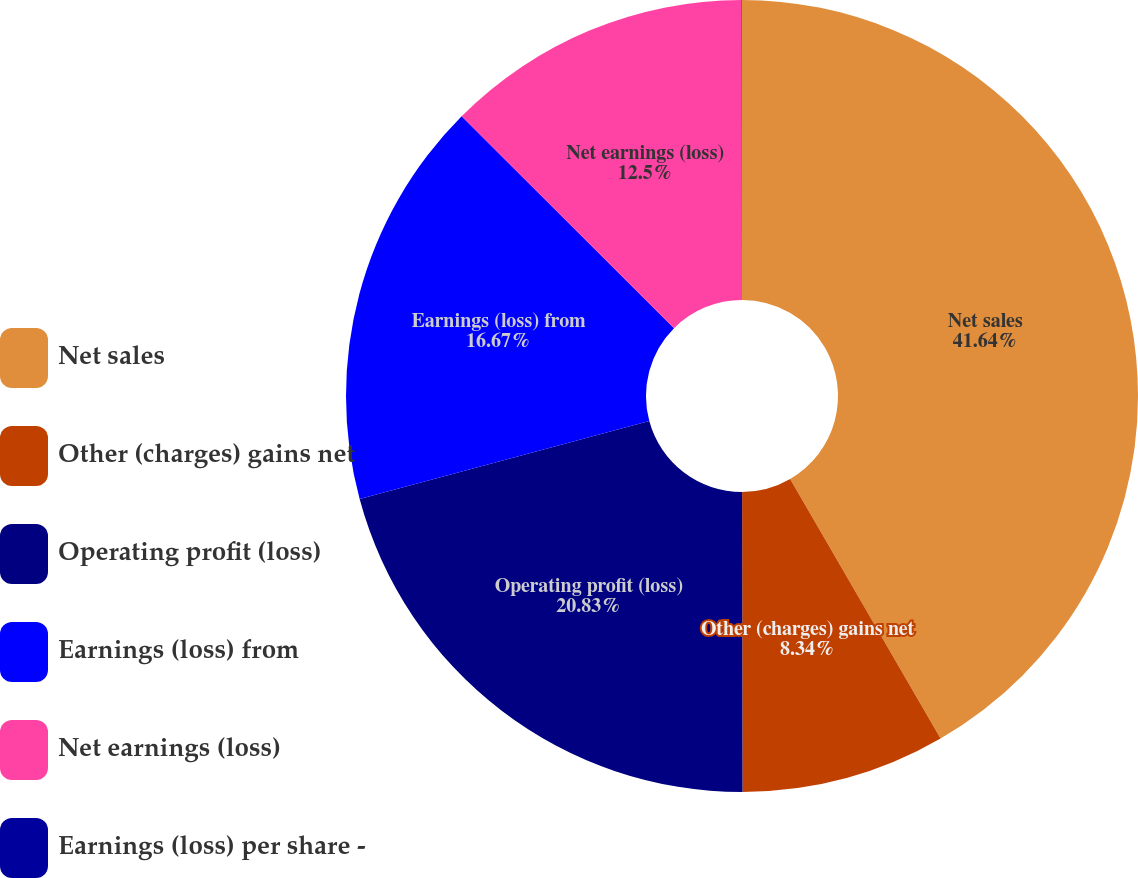Convert chart to OTSL. <chart><loc_0><loc_0><loc_500><loc_500><pie_chart><fcel>Net sales<fcel>Other (charges) gains net<fcel>Operating profit (loss)<fcel>Earnings (loss) from<fcel>Net earnings (loss)<fcel>Earnings (loss) per share -<nl><fcel>41.64%<fcel>8.34%<fcel>20.83%<fcel>16.67%<fcel>12.5%<fcel>0.02%<nl></chart> 